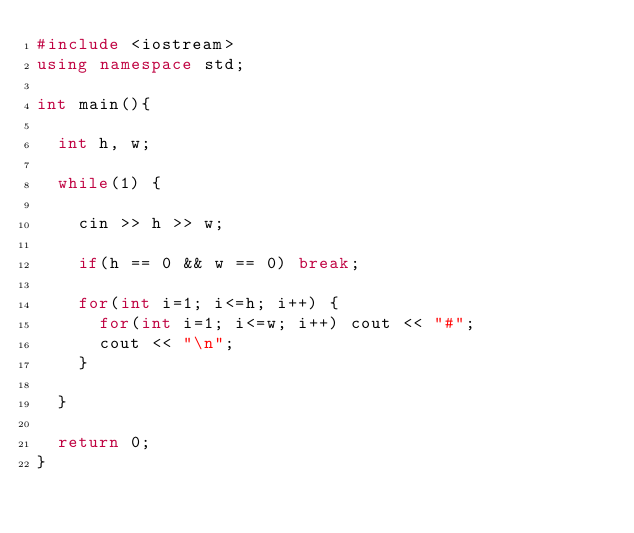Convert code to text. <code><loc_0><loc_0><loc_500><loc_500><_C++_>#include <iostream>
using namespace std;

int main(){

  int h, w;

  while(1) {

    cin >> h >> w;

    if(h == 0 && w == 0) break;
    
    for(int i=1; i<=h; i++) {
      for(int i=1; i<=w; i++) cout << "#";
      cout << "\n";  
    }

  }
    
  return 0;
}</code> 